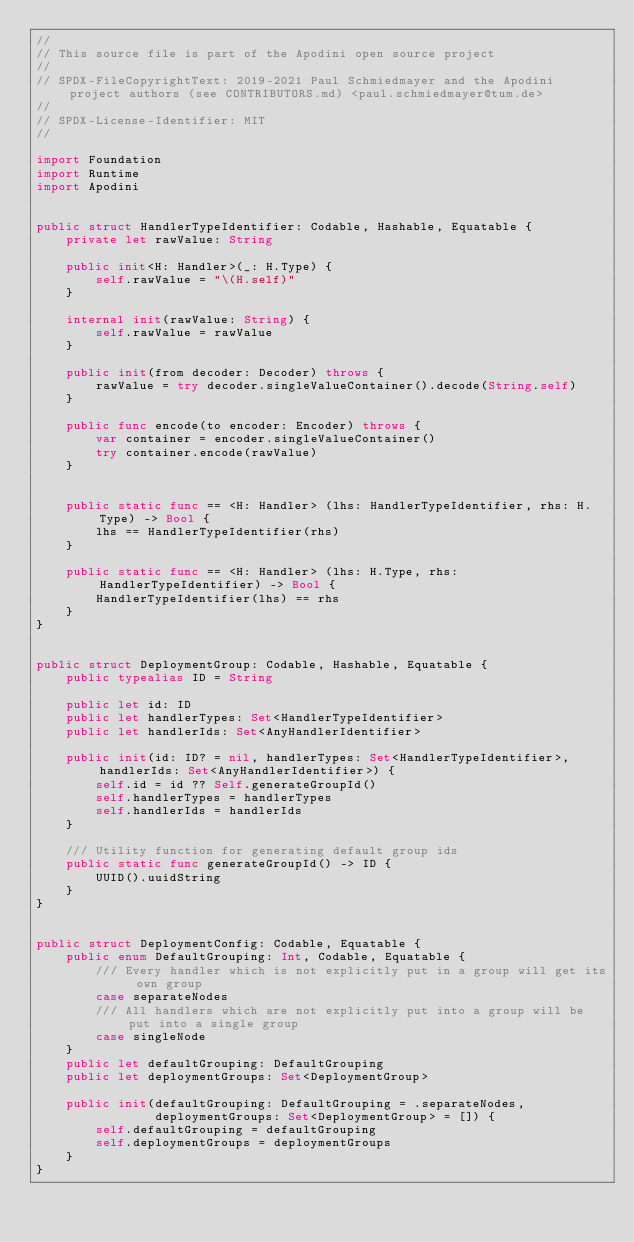Convert code to text. <code><loc_0><loc_0><loc_500><loc_500><_Swift_>//                   
// This source file is part of the Apodini open source project
//
// SPDX-FileCopyrightText: 2019-2021 Paul Schmiedmayer and the Apodini project authors (see CONTRIBUTORS.md) <paul.schmiedmayer@tum.de>
//
// SPDX-License-Identifier: MIT
//              

import Foundation
import Runtime
import Apodini


public struct HandlerTypeIdentifier: Codable, Hashable, Equatable {
    private let rawValue: String
    
    public init<H: Handler>(_: H.Type) {
        self.rawValue = "\(H.self)"
    }
    
    internal init(rawValue: String) {
        self.rawValue = rawValue
    }
    
    public init(from decoder: Decoder) throws {
        rawValue = try decoder.singleValueContainer().decode(String.self)
    }
    
    public func encode(to encoder: Encoder) throws {
        var container = encoder.singleValueContainer()
        try container.encode(rawValue)
    }
    
    
    public static func == <H: Handler> (lhs: HandlerTypeIdentifier, rhs: H.Type) -> Bool {
        lhs == HandlerTypeIdentifier(rhs)
    }
    
    public static func == <H: Handler> (lhs: H.Type, rhs: HandlerTypeIdentifier) -> Bool {
        HandlerTypeIdentifier(lhs) == rhs
    }
}


public struct DeploymentGroup: Codable, Hashable, Equatable {
    public typealias ID = String
    
    public let id: ID
    public let handlerTypes: Set<HandlerTypeIdentifier>
    public let handlerIds: Set<AnyHandlerIdentifier>
    
    public init(id: ID? = nil, handlerTypes: Set<HandlerTypeIdentifier>, handlerIds: Set<AnyHandlerIdentifier>) {
        self.id = id ?? Self.generateGroupId()
        self.handlerTypes = handlerTypes
        self.handlerIds = handlerIds
    }
    
    /// Utility function for generating default group ids
    public static func generateGroupId() -> ID {
        UUID().uuidString
    }
}


public struct DeploymentConfig: Codable, Equatable {
    public enum DefaultGrouping: Int, Codable, Equatable {
        /// Every handler which is not explicitly put in a group will get its own group
        case separateNodes
        /// All handlers which are not explicitly put into a group will be put into a single group
        case singleNode
    }
    public let defaultGrouping: DefaultGrouping
    public let deploymentGroups: Set<DeploymentGroup>
    
    public init(defaultGrouping: DefaultGrouping = .separateNodes,
                deploymentGroups: Set<DeploymentGroup> = []) {
        self.defaultGrouping = defaultGrouping
        self.deploymentGroups = deploymentGroups
    }
}
</code> 